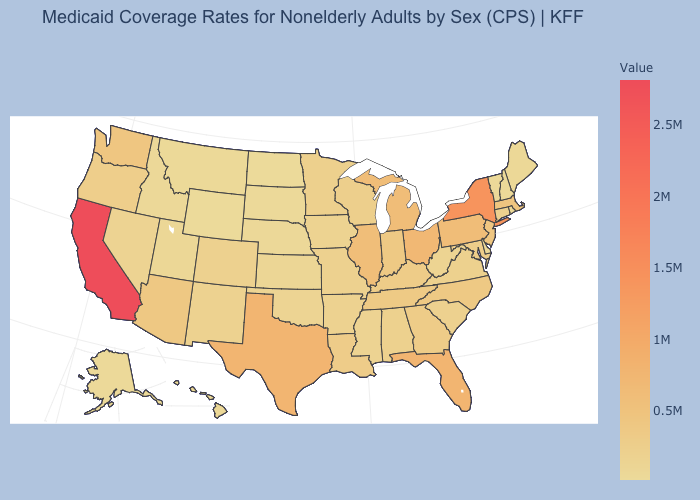Does the map have missing data?
Answer briefly. No. Among the states that border South Dakota , which have the lowest value?
Write a very short answer. Wyoming. Which states have the lowest value in the South?
Write a very short answer. Delaware. Among the states that border Indiana , which have the highest value?
Quick response, please. Ohio. Is the legend a continuous bar?
Give a very brief answer. Yes. Among the states that border Washington , does Idaho have the highest value?
Keep it brief. No. Which states have the lowest value in the MidWest?
Write a very short answer. North Dakota. Does Maryland have the lowest value in the USA?
Concise answer only. No. 